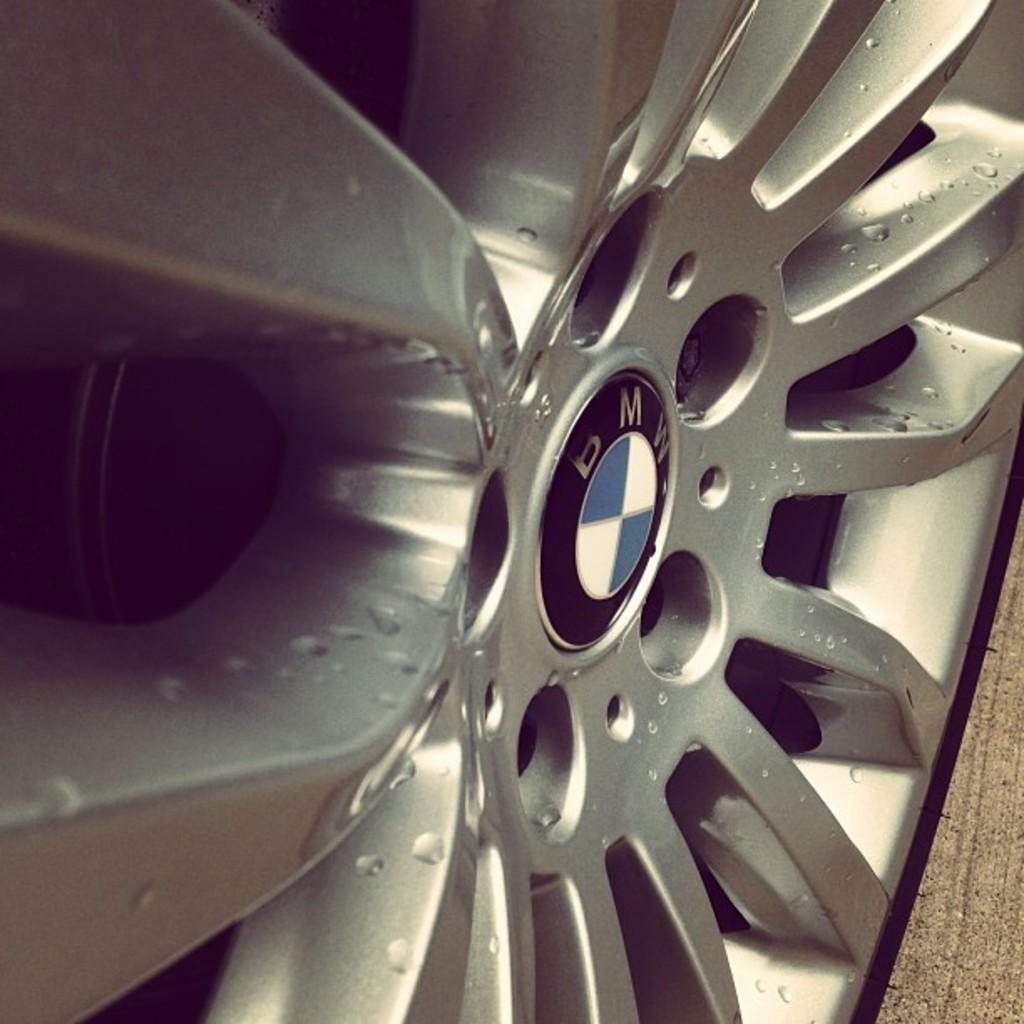What type of object is featured in the image? There is a part of a vehicle in the image. What can be seen on the vehicle part? A logo and some text are visible on the part of the vehicle. What type of toys can be seen on the clock in the image? There is no clock or toys present in the image; it features a part of a vehicle with a logo and text. 